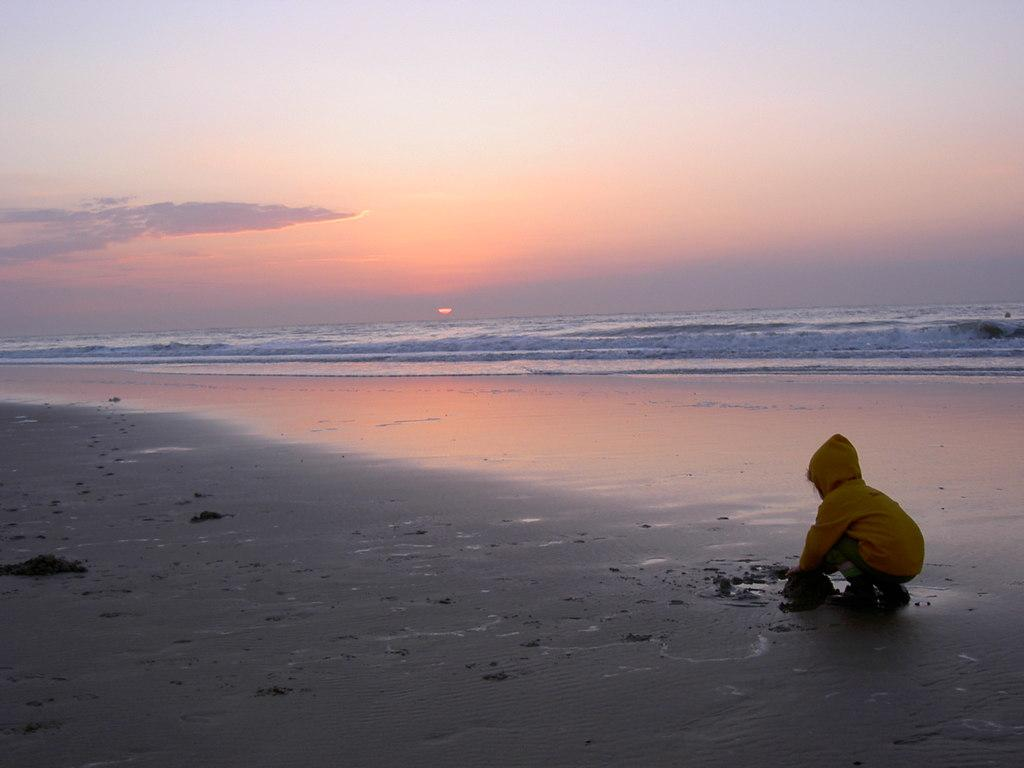What is the main subject of the image? The main subject of the image is a kid. Where is the kid located in the image? The kid is on the sea shore. What can be observed about the sky in the image? The image depicts a sunset. What is the weight of the pencil in the image? There is no pencil present in the image, so it is not possible to determine its weight. 